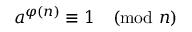Convert formula to latex. <formula><loc_0><loc_0><loc_500><loc_500>a ^ { \varphi ( n ) } \equiv 1 { \pmod { n } }</formula> 